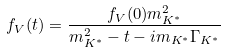<formula> <loc_0><loc_0><loc_500><loc_500>f _ { V } ( t ) = \frac { f _ { V } ( 0 ) m _ { K ^ { \ast } } ^ { 2 } } { m _ { K ^ { \ast } } ^ { 2 } - t - i m _ { K ^ { \ast } } \Gamma _ { K ^ { \ast } } }</formula> 